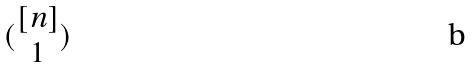Convert formula to latex. <formula><loc_0><loc_0><loc_500><loc_500>( \begin{matrix} [ n ] \\ 1 \end{matrix} )</formula> 